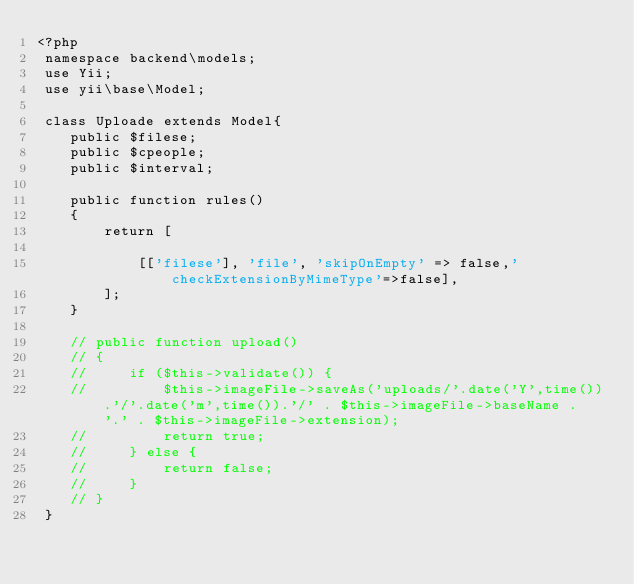Convert code to text. <code><loc_0><loc_0><loc_500><loc_500><_PHP_><?php
 namespace backend\models;
 use Yii;
 use yii\base\Model;
 
 class Uploade extends Model{
    public $filese;
    public $cpeople;
    public $interval;

    public function rules()
    {
        return [
  
            [['filese'], 'file', 'skipOnEmpty' => false,'checkExtensionByMimeType'=>false],
        ];
    }
    
    // public function upload()
    // {
    //     if ($this->validate()) {
    //         $this->imageFile->saveAs('uploads/'.date('Y',time()).'/'.date('m',time()).'/' . $this->imageFile->baseName . '.' . $this->imageFile->extension);
    //         return true;
    //     } else {
    //         return false;
    //     }
    // }
 } </code> 